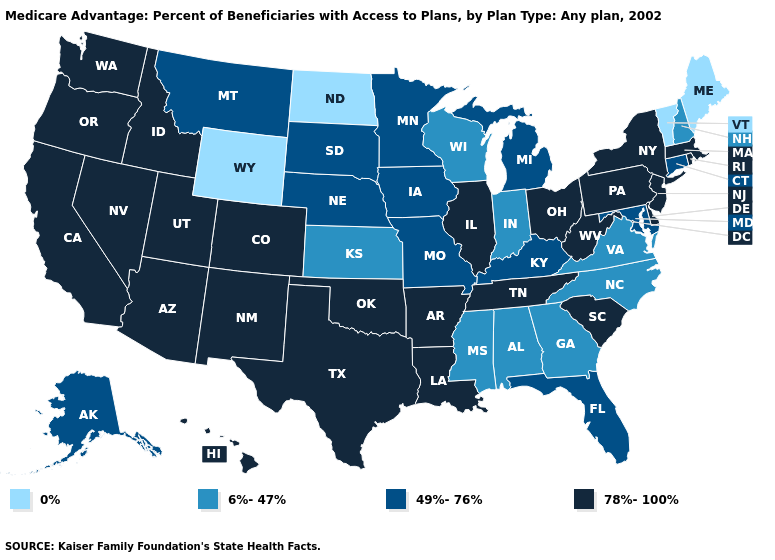What is the highest value in states that border North Dakota?
Quick response, please. 49%-76%. How many symbols are there in the legend?
Keep it brief. 4. Among the states that border Kentucky , which have the lowest value?
Answer briefly. Indiana, Virginia. Which states have the lowest value in the MidWest?
Be succinct. North Dakota. Does Oklahoma have a lower value than Connecticut?
Give a very brief answer. No. Name the states that have a value in the range 6%-47%?
Give a very brief answer. Alabama, Georgia, Indiana, Kansas, Mississippi, North Carolina, New Hampshire, Virginia, Wisconsin. Name the states that have a value in the range 0%?
Answer briefly. Maine, North Dakota, Vermont, Wyoming. Among the states that border South Dakota , which have the lowest value?
Quick response, please. North Dakota, Wyoming. Which states have the highest value in the USA?
Answer briefly. Arkansas, Arizona, California, Colorado, Delaware, Hawaii, Idaho, Illinois, Louisiana, Massachusetts, New Jersey, New Mexico, Nevada, New York, Ohio, Oklahoma, Oregon, Pennsylvania, Rhode Island, South Carolina, Tennessee, Texas, Utah, Washington, West Virginia. Among the states that border Virginia , does West Virginia have the lowest value?
Write a very short answer. No. Name the states that have a value in the range 0%?
Concise answer only. Maine, North Dakota, Vermont, Wyoming. What is the value of Nebraska?
Concise answer only. 49%-76%. What is the value of Nevada?
Be succinct. 78%-100%. What is the value of Minnesota?
Write a very short answer. 49%-76%. 